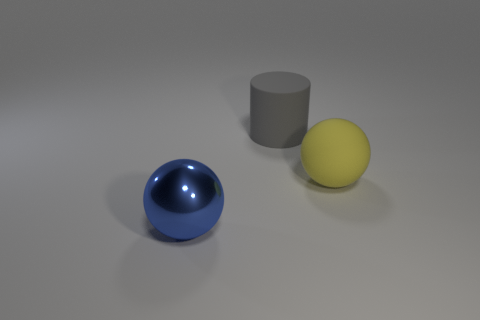What number of things are balls in front of the big yellow object or yellow things?
Keep it short and to the point. 2. There is a big rubber object that is on the left side of the ball that is right of the thing in front of the yellow object; what is its shape?
Your answer should be compact. Cylinder. How many blue things are the same shape as the yellow object?
Make the answer very short. 1. Do the gray cylinder and the big blue thing have the same material?
Offer a terse response. No. There is a ball that is behind the big ball on the left side of the gray thing; how many large matte things are behind it?
Ensure brevity in your answer.  1. Is there a yellow sphere made of the same material as the gray object?
Make the answer very short. Yes. Are there fewer large rubber objects than gray things?
Make the answer very short. No. There is a large ball in front of the large ball to the right of the sphere left of the big yellow rubber ball; what is its material?
Make the answer very short. Metal. Are there fewer gray matte cylinders on the left side of the shiny object than tiny red metal cylinders?
Provide a short and direct response. No. There is a rubber object to the right of the gray rubber thing; is it the same size as the blue shiny ball?
Provide a short and direct response. Yes. 